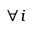Convert formula to latex. <formula><loc_0><loc_0><loc_500><loc_500>\forall i</formula> 